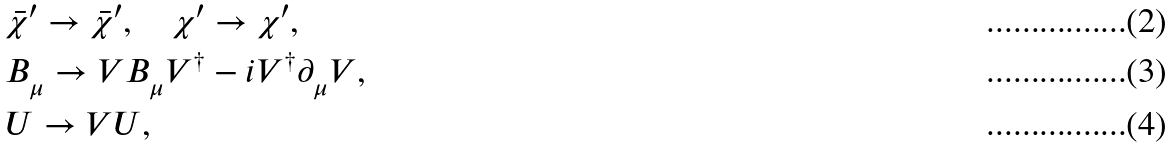<formula> <loc_0><loc_0><loc_500><loc_500>& \bar { \chi } ^ { \prime } \to \bar { \chi } ^ { \prime } , \quad \chi ^ { \prime } \to \chi ^ { \prime } , \\ & B ^ { \ } _ { \mu } \to V B ^ { \ } _ { \mu } V ^ { \dag } - { i } V ^ { \dag } \partial ^ { \ } _ { \mu } V , \\ & U \to V U ,</formula> 